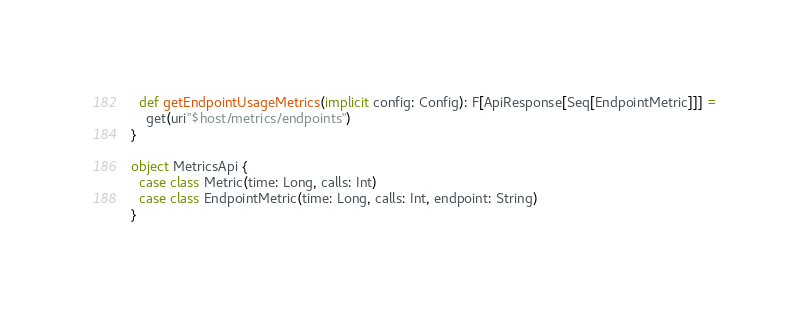<code> <loc_0><loc_0><loc_500><loc_500><_Scala_>  def getEndpointUsageMetrics(implicit config: Config): F[ApiResponse[Seq[EndpointMetric]]] =
    get(uri"$host/metrics/endpoints")
}

object MetricsApi {
  case class Metric(time: Long, calls: Int)
  case class EndpointMetric(time: Long, calls: Int, endpoint: String)
}
</code> 